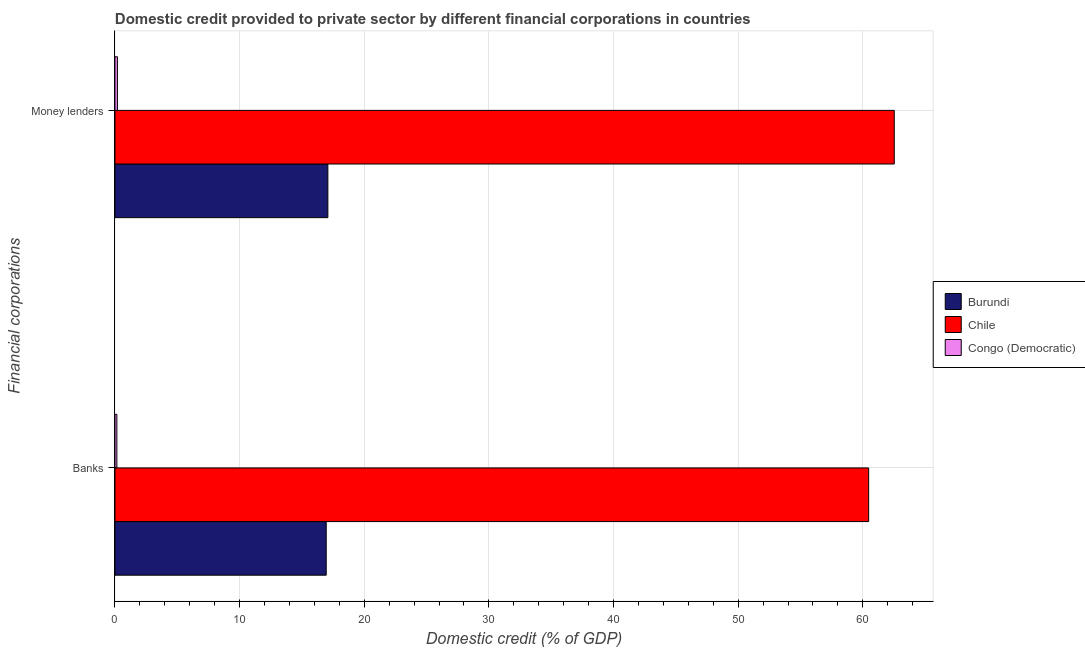How many groups of bars are there?
Provide a succinct answer. 2. How many bars are there on the 2nd tick from the top?
Your response must be concise. 3. How many bars are there on the 2nd tick from the bottom?
Offer a very short reply. 3. What is the label of the 1st group of bars from the top?
Provide a short and direct response. Money lenders. What is the domestic credit provided by banks in Burundi?
Offer a terse response. 16.95. Across all countries, what is the maximum domestic credit provided by money lenders?
Offer a terse response. 62.52. Across all countries, what is the minimum domestic credit provided by money lenders?
Offer a terse response. 0.2. In which country was the domestic credit provided by money lenders maximum?
Your answer should be compact. Chile. In which country was the domestic credit provided by money lenders minimum?
Provide a short and direct response. Congo (Democratic). What is the total domestic credit provided by banks in the graph?
Make the answer very short. 77.57. What is the difference between the domestic credit provided by banks in Burundi and that in Congo (Democratic)?
Offer a terse response. 16.79. What is the difference between the domestic credit provided by money lenders in Chile and the domestic credit provided by banks in Burundi?
Your response must be concise. 45.57. What is the average domestic credit provided by banks per country?
Offer a terse response. 25.86. What is the difference between the domestic credit provided by money lenders and domestic credit provided by banks in Congo (Democratic)?
Your response must be concise. 0.04. In how many countries, is the domestic credit provided by money lenders greater than 2 %?
Your answer should be compact. 2. What is the ratio of the domestic credit provided by banks in Chile to that in Burundi?
Your answer should be very brief. 3.57. Is the domestic credit provided by banks in Burundi less than that in Chile?
Your response must be concise. Yes. What does the 3rd bar from the top in Money lenders represents?
Give a very brief answer. Burundi. What does the 1st bar from the bottom in Banks represents?
Offer a terse response. Burundi. How many bars are there?
Ensure brevity in your answer.  6. Are all the bars in the graph horizontal?
Ensure brevity in your answer.  Yes. What is the difference between two consecutive major ticks on the X-axis?
Make the answer very short. 10. Where does the legend appear in the graph?
Give a very brief answer. Center right. How are the legend labels stacked?
Give a very brief answer. Vertical. What is the title of the graph?
Make the answer very short. Domestic credit provided to private sector by different financial corporations in countries. What is the label or title of the X-axis?
Provide a short and direct response. Domestic credit (% of GDP). What is the label or title of the Y-axis?
Your answer should be very brief. Financial corporations. What is the Domestic credit (% of GDP) of Burundi in Banks?
Ensure brevity in your answer.  16.95. What is the Domestic credit (% of GDP) in Chile in Banks?
Make the answer very short. 60.47. What is the Domestic credit (% of GDP) in Congo (Democratic) in Banks?
Provide a succinct answer. 0.15. What is the Domestic credit (% of GDP) in Burundi in Money lenders?
Provide a short and direct response. 17.08. What is the Domestic credit (% of GDP) in Chile in Money lenders?
Your answer should be very brief. 62.52. What is the Domestic credit (% of GDP) in Congo (Democratic) in Money lenders?
Your response must be concise. 0.2. Across all Financial corporations, what is the maximum Domestic credit (% of GDP) of Burundi?
Provide a succinct answer. 17.08. Across all Financial corporations, what is the maximum Domestic credit (% of GDP) of Chile?
Your response must be concise. 62.52. Across all Financial corporations, what is the maximum Domestic credit (% of GDP) in Congo (Democratic)?
Offer a very short reply. 0.2. Across all Financial corporations, what is the minimum Domestic credit (% of GDP) in Burundi?
Keep it short and to the point. 16.95. Across all Financial corporations, what is the minimum Domestic credit (% of GDP) of Chile?
Keep it short and to the point. 60.47. Across all Financial corporations, what is the minimum Domestic credit (% of GDP) in Congo (Democratic)?
Your answer should be very brief. 0.15. What is the total Domestic credit (% of GDP) of Burundi in the graph?
Provide a short and direct response. 34.03. What is the total Domestic credit (% of GDP) in Chile in the graph?
Make the answer very short. 122.99. What is the total Domestic credit (% of GDP) in Congo (Democratic) in the graph?
Make the answer very short. 0.35. What is the difference between the Domestic credit (% of GDP) in Burundi in Banks and that in Money lenders?
Offer a very short reply. -0.13. What is the difference between the Domestic credit (% of GDP) in Chile in Banks and that in Money lenders?
Make the answer very short. -2.05. What is the difference between the Domestic credit (% of GDP) in Congo (Democratic) in Banks and that in Money lenders?
Your answer should be compact. -0.04. What is the difference between the Domestic credit (% of GDP) in Burundi in Banks and the Domestic credit (% of GDP) in Chile in Money lenders?
Provide a short and direct response. -45.57. What is the difference between the Domestic credit (% of GDP) in Burundi in Banks and the Domestic credit (% of GDP) in Congo (Democratic) in Money lenders?
Offer a very short reply. 16.75. What is the difference between the Domestic credit (% of GDP) of Chile in Banks and the Domestic credit (% of GDP) of Congo (Democratic) in Money lenders?
Your response must be concise. 60.27. What is the average Domestic credit (% of GDP) in Burundi per Financial corporations?
Provide a short and direct response. 17.01. What is the average Domestic credit (% of GDP) of Chile per Financial corporations?
Make the answer very short. 61.49. What is the average Domestic credit (% of GDP) of Congo (Democratic) per Financial corporations?
Your answer should be very brief. 0.18. What is the difference between the Domestic credit (% of GDP) in Burundi and Domestic credit (% of GDP) in Chile in Banks?
Offer a very short reply. -43.52. What is the difference between the Domestic credit (% of GDP) of Burundi and Domestic credit (% of GDP) of Congo (Democratic) in Banks?
Offer a terse response. 16.79. What is the difference between the Domestic credit (% of GDP) in Chile and Domestic credit (% of GDP) in Congo (Democratic) in Banks?
Give a very brief answer. 60.31. What is the difference between the Domestic credit (% of GDP) in Burundi and Domestic credit (% of GDP) in Chile in Money lenders?
Ensure brevity in your answer.  -45.44. What is the difference between the Domestic credit (% of GDP) of Burundi and Domestic credit (% of GDP) of Congo (Democratic) in Money lenders?
Make the answer very short. 16.88. What is the difference between the Domestic credit (% of GDP) of Chile and Domestic credit (% of GDP) of Congo (Democratic) in Money lenders?
Ensure brevity in your answer.  62.32. What is the ratio of the Domestic credit (% of GDP) in Chile in Banks to that in Money lenders?
Keep it short and to the point. 0.97. What is the ratio of the Domestic credit (% of GDP) in Congo (Democratic) in Banks to that in Money lenders?
Offer a very short reply. 0.78. What is the difference between the highest and the second highest Domestic credit (% of GDP) in Burundi?
Offer a very short reply. 0.13. What is the difference between the highest and the second highest Domestic credit (% of GDP) of Chile?
Your answer should be very brief. 2.05. What is the difference between the highest and the second highest Domestic credit (% of GDP) in Congo (Democratic)?
Your response must be concise. 0.04. What is the difference between the highest and the lowest Domestic credit (% of GDP) in Burundi?
Keep it short and to the point. 0.13. What is the difference between the highest and the lowest Domestic credit (% of GDP) of Chile?
Make the answer very short. 2.05. What is the difference between the highest and the lowest Domestic credit (% of GDP) in Congo (Democratic)?
Provide a short and direct response. 0.04. 